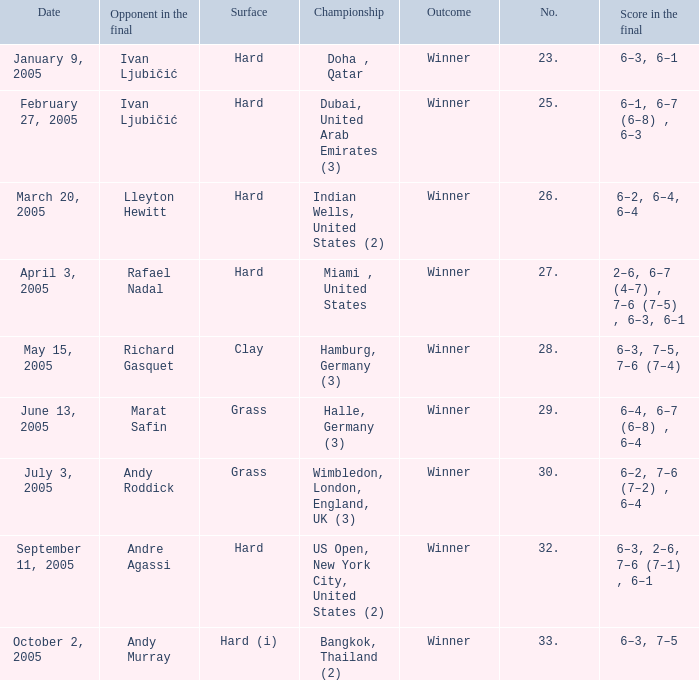Marat Safin is the opponent in the final in what championship? Halle, Germany (3). 